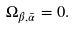<formula> <loc_0><loc_0><loc_500><loc_500>\Omega _ { \beta , \bar { \alpha } } = 0 .</formula> 